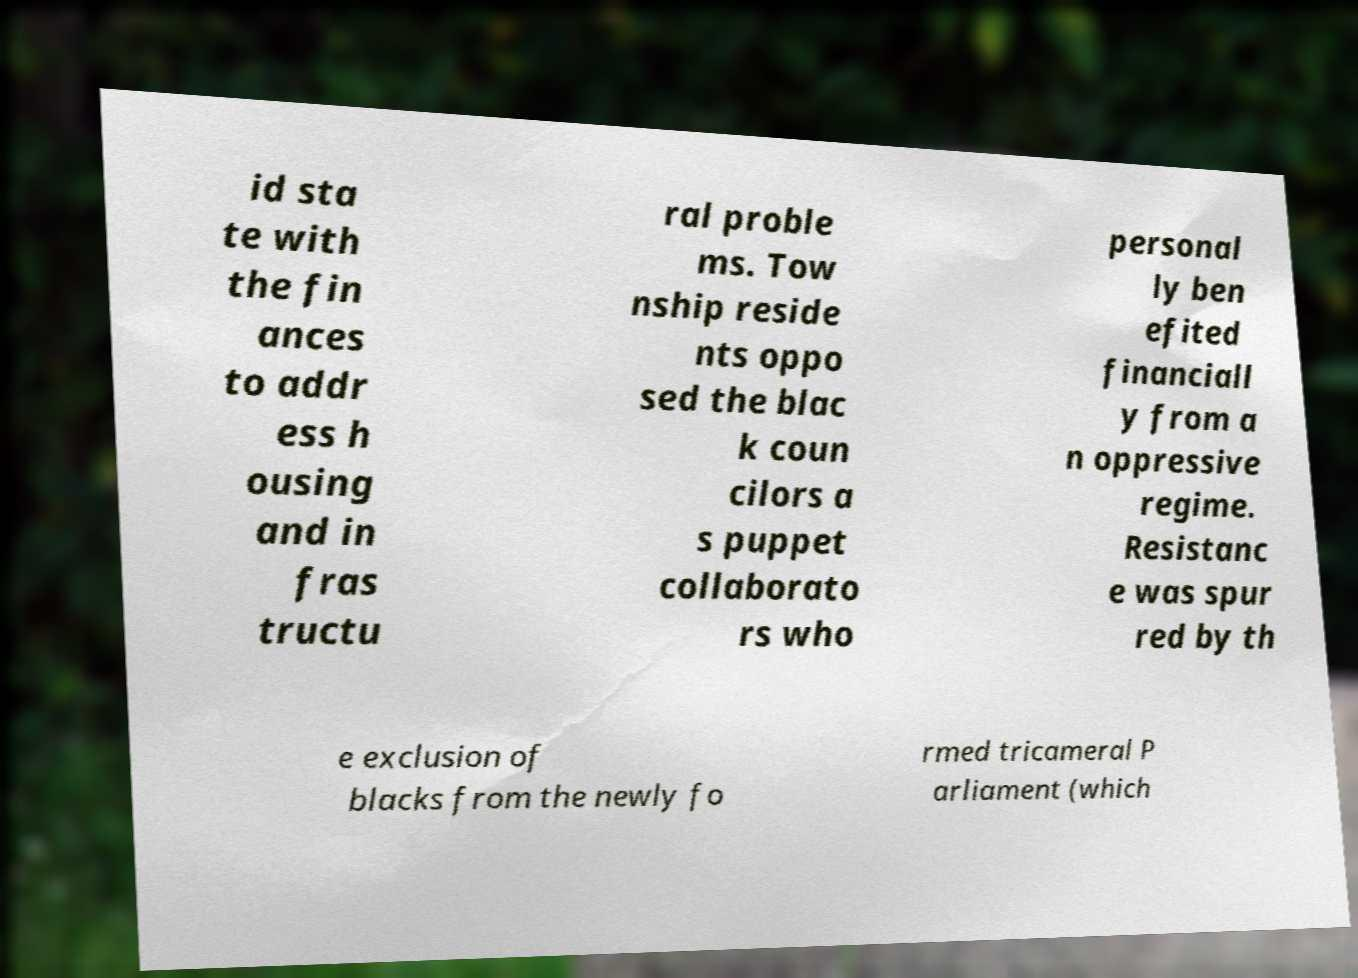Can you accurately transcribe the text from the provided image for me? id sta te with the fin ances to addr ess h ousing and in fras tructu ral proble ms. Tow nship reside nts oppo sed the blac k coun cilors a s puppet collaborato rs who personal ly ben efited financiall y from a n oppressive regime. Resistanc e was spur red by th e exclusion of blacks from the newly fo rmed tricameral P arliament (which 